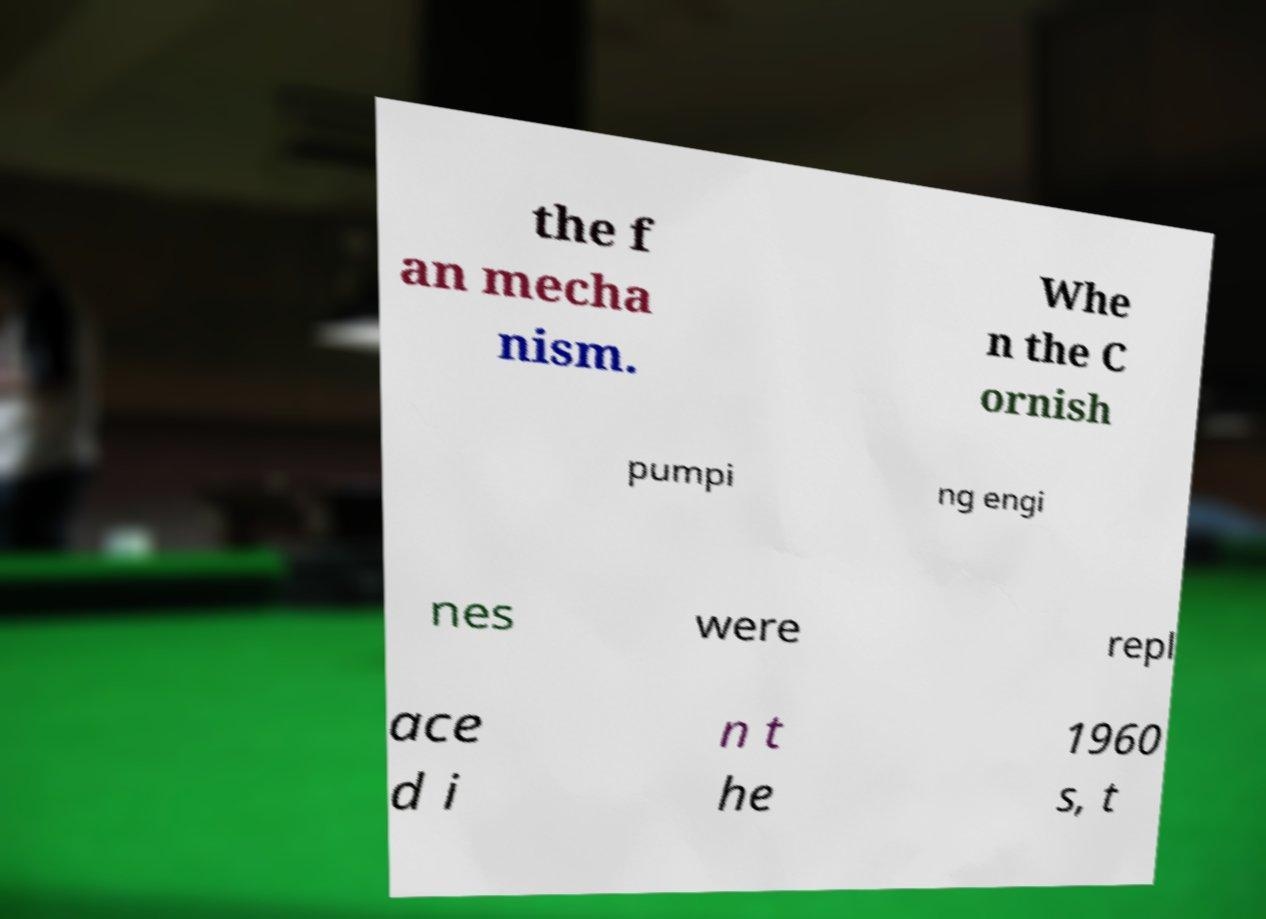Can you accurately transcribe the text from the provided image for me? the f an mecha nism. Whe n the C ornish pumpi ng engi nes were repl ace d i n t he 1960 s, t 